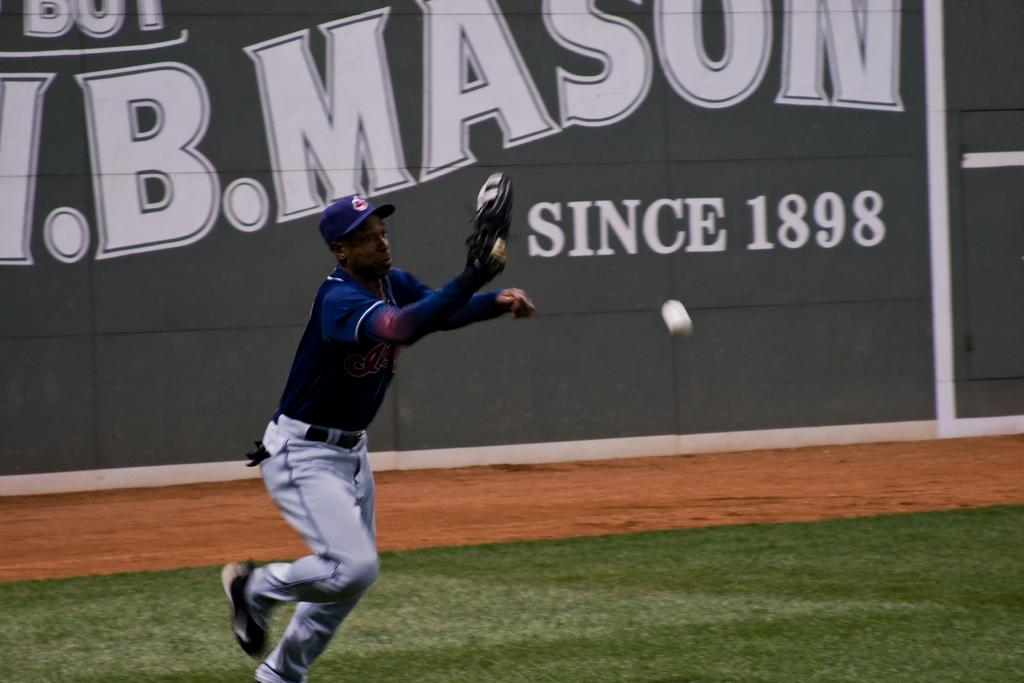<image>
Describe the image concisely. a man throwing a ball with a sign reading 'since 1898' behind him. 